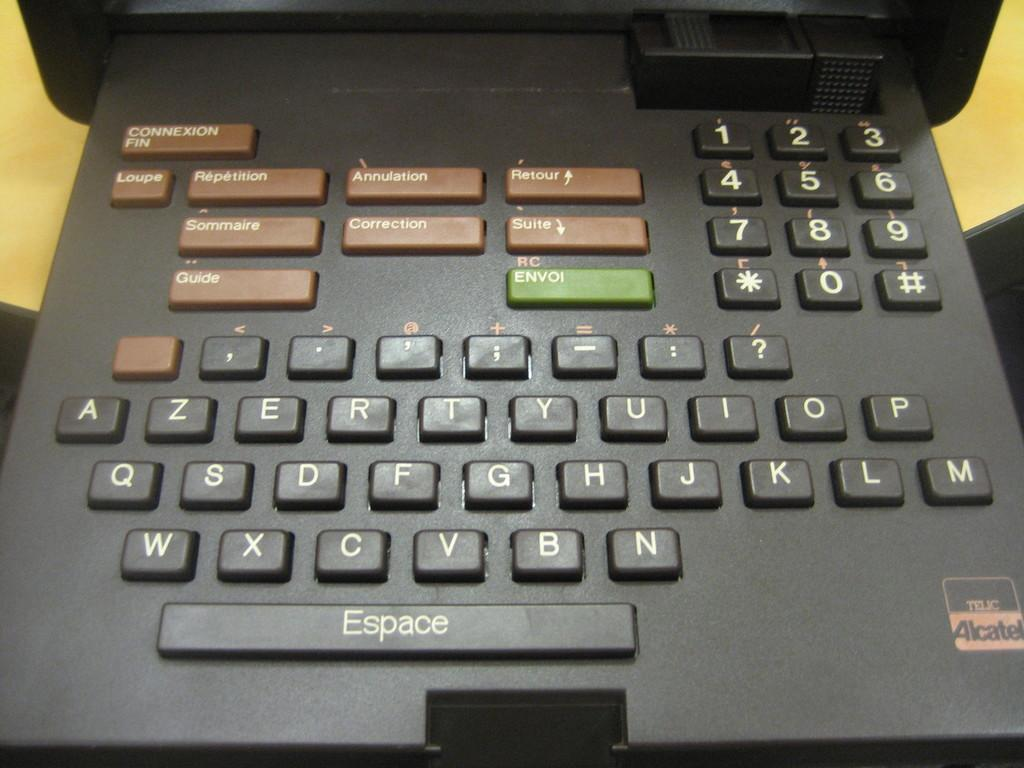<image>
Give a short and clear explanation of the subsequent image. A keyboard for an Alcatel Telic with a keyboard and number pad, and buttons for connection and guide. 